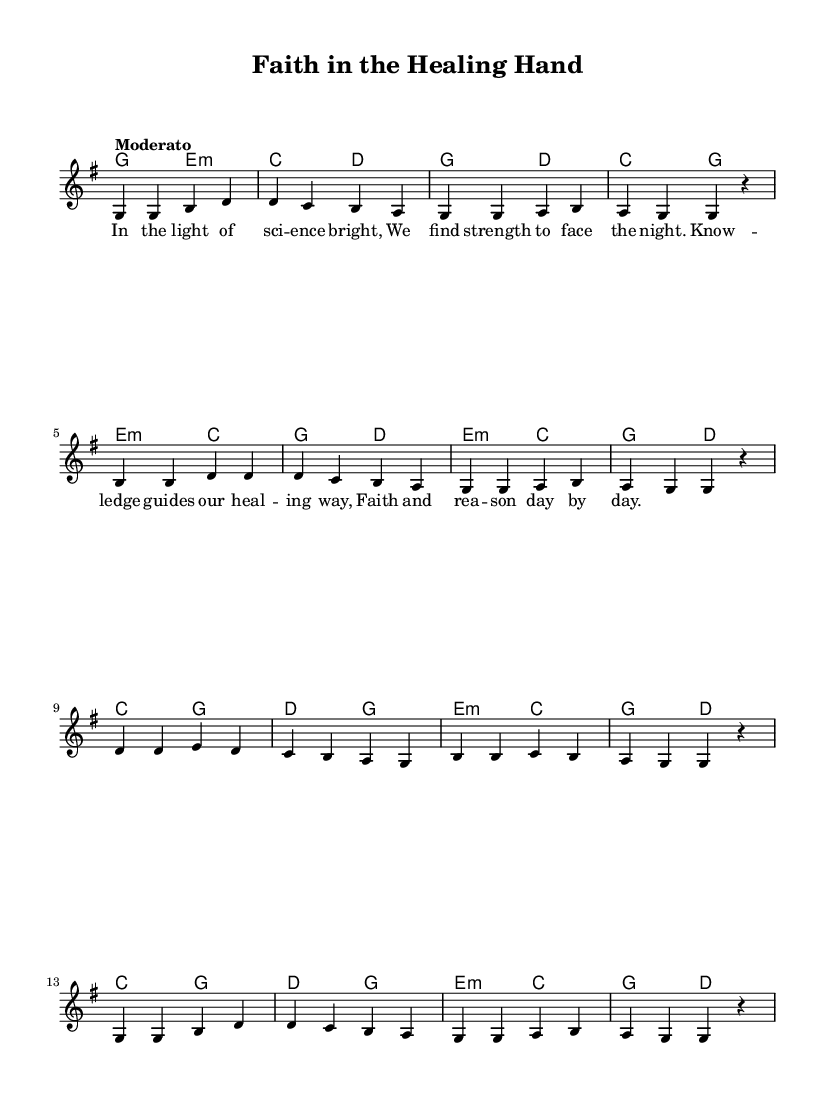What is the key signature of this music? The key signature is G major, which has one sharp (F#).
Answer: G major What is the time signature of this music? The time signature is 4/4, indicating four beats per measure.
Answer: 4/4 What is the tempo marking of this music? The tempo marking is "Moderato," suggesting a moderate pace.
Answer: Moderato How many measures are in the piece? There are 16 measures, as counted in the staff.
Answer: 16 What is the main theme of the lyrics? The lyrics focus on the relationship between science and faith in the healing process.
Answer: Faith and healing What are the starting notes of the melody? The melody starts on the note G in the first measure.
Answer: G How do the harmonies support the melody? The harmonies provide a rich accompaniment that complements the melody's emotional tone, emphasizing the theme of healing through faith and knowledge.
Answer: They support the emotional tone 